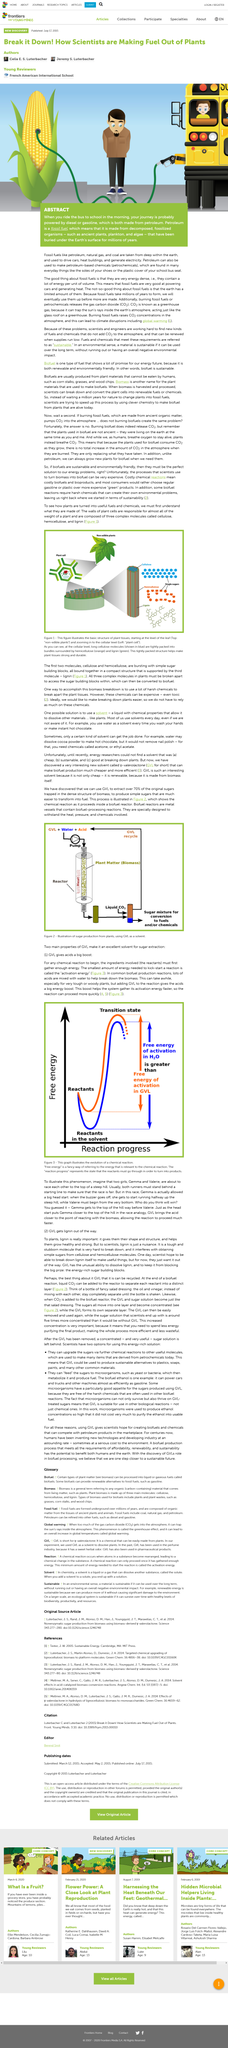Indicate a few pertinent items in this graphic. Figure 1 provides a visual representation of the fundamental composition of plant tissues, which consist of various types of cells that work together to support the growth and function of plants. GVL is a renewable fuel source because it is made from biomass, which is organic matter derived from living or recently living organisms. I am proud to announce that the newly discovered solvent, produced from biomass and known as y-valerolactone, has been designated the acronym GVL. The graph in Figure 3 illustrates the evolution of a chemical reaction over time. Activation energy is the minimum amount of energy required to initiate a chemical reaction. 